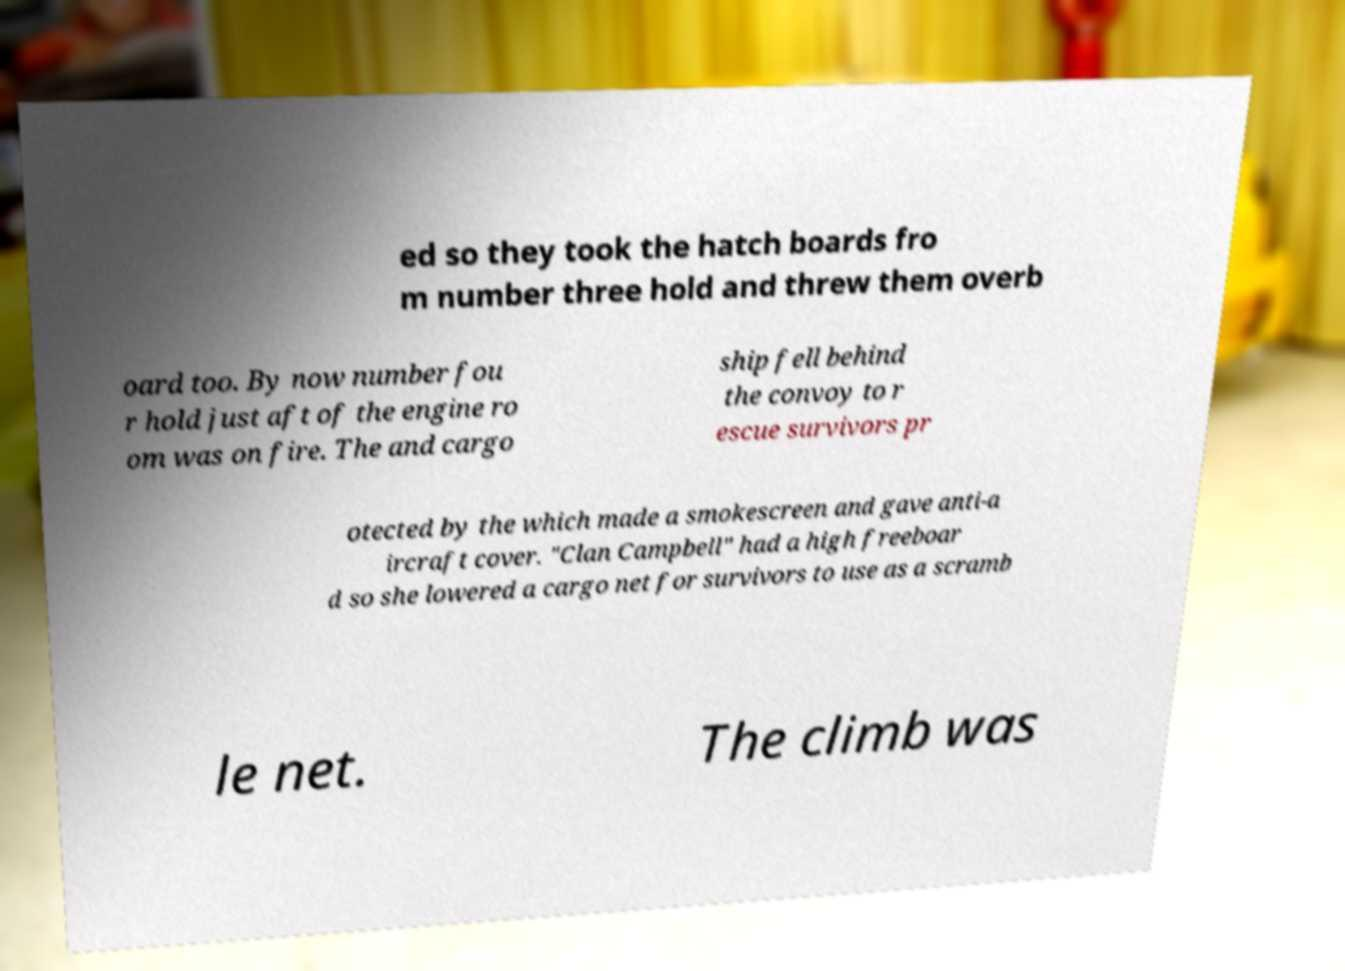What messages or text are displayed in this image? I need them in a readable, typed format. ed so they took the hatch boards fro m number three hold and threw them overb oard too. By now number fou r hold just aft of the engine ro om was on fire. The and cargo ship fell behind the convoy to r escue survivors pr otected by the which made a smokescreen and gave anti-a ircraft cover. "Clan Campbell" had a high freeboar d so she lowered a cargo net for survivors to use as a scramb le net. The climb was 